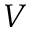<formula> <loc_0><loc_0><loc_500><loc_500>V</formula> 